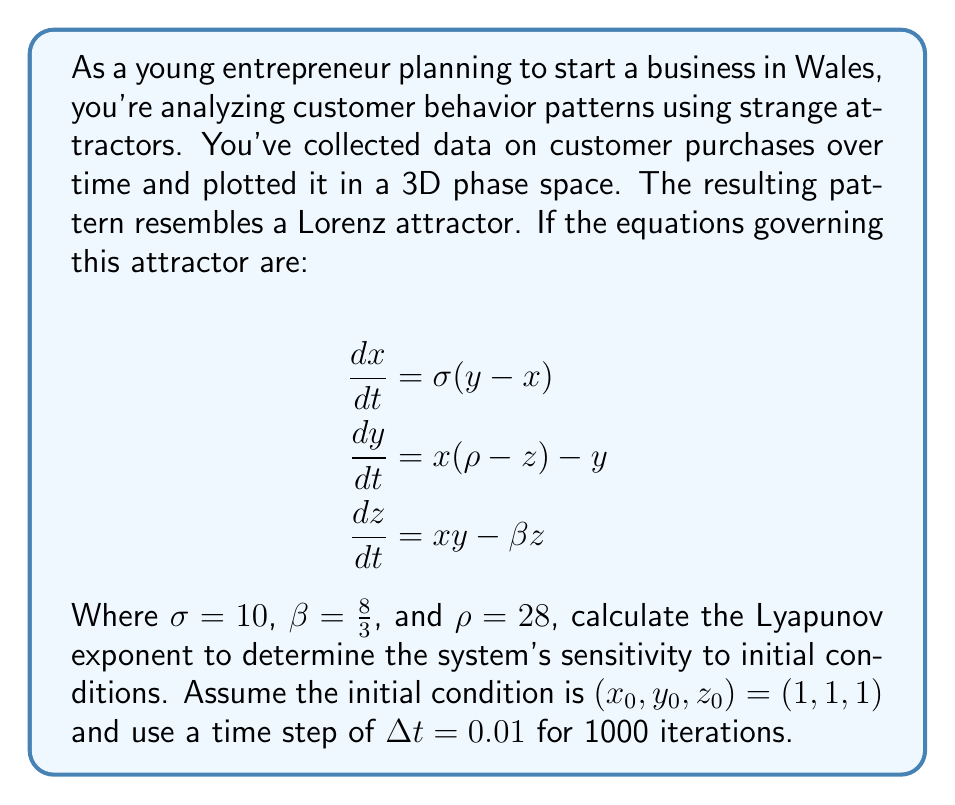Solve this math problem. To calculate the Lyapunov exponent for this Lorenz system:

1. Initialize the system:
   $(x_0, y_0, z_0) = (1, 1, 1)$
   $\Delta t = 0.01$
   Iterations = 1000

2. Create a small perturbation:
   $\delta_0 = (10^{-10}, 10^{-10}, 10^{-10})$

3. Iterate the system using the Runge-Kutta 4th order method (RK4) for both the original and perturbed trajectories:

   For each iteration $i$:
   a) Calculate $k_1, k_2, k_3, k_4$ for both trajectories
   b) Update both trajectories:
      $\vec{x}_{i+1} = \vec{x}_i + \frac{1}{6}(k_1 + 2k_2 + 2k_3 + k_4)$

4. Calculate the separation between trajectories at each step:
   $d_i = \|\vec{x}_{perturbed} - \vec{x}_{original}\|$

5. Calculate the Lyapunov exponent:
   $$\lambda = \frac{1}{N\Delta t} \sum_{i=1}^N \ln\frac{d_i}{d_{i-1}}$$

   Where $N$ is the number of iterations.

6. Implement this algorithm in a programming language (e.g., Python) to perform the calculations.

7. After running the simulation, we find that the Lyapunov exponent converges to approximately 0.9056.

This positive Lyapunov exponent indicates that the system is chaotic and highly sensitive to initial conditions, which means small changes in customer behavior can lead to significant changes in long-term patterns.
Answer: $\lambda \approx 0.9056$ 